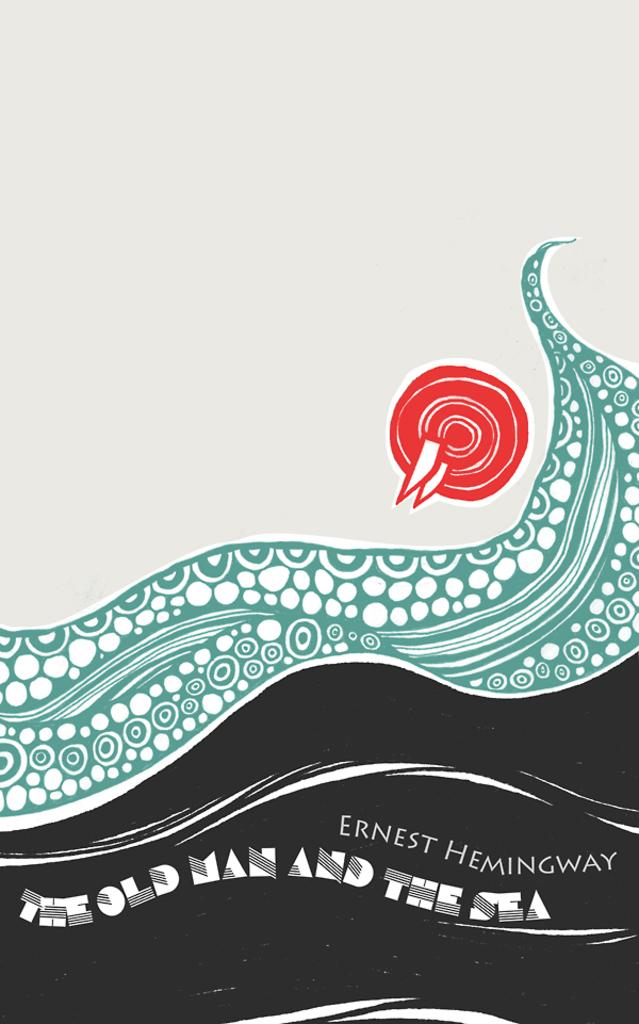<image>
Relay a brief, clear account of the picture shown. The sea's wave washing over the old man. 